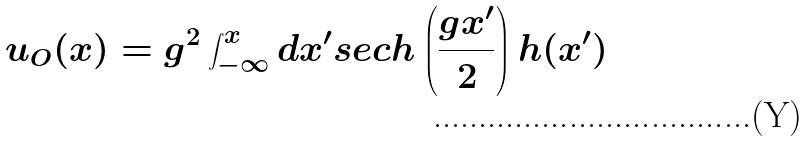Convert formula to latex. <formula><loc_0><loc_0><loc_500><loc_500>u _ { O } ( x ) = g ^ { 2 } \int ^ { x } _ { - \infty } { d x ^ { \prime } } s e c h \left ( \frac { g x ^ { \prime } } { 2 } \right ) h ( x ^ { \prime } )</formula> 